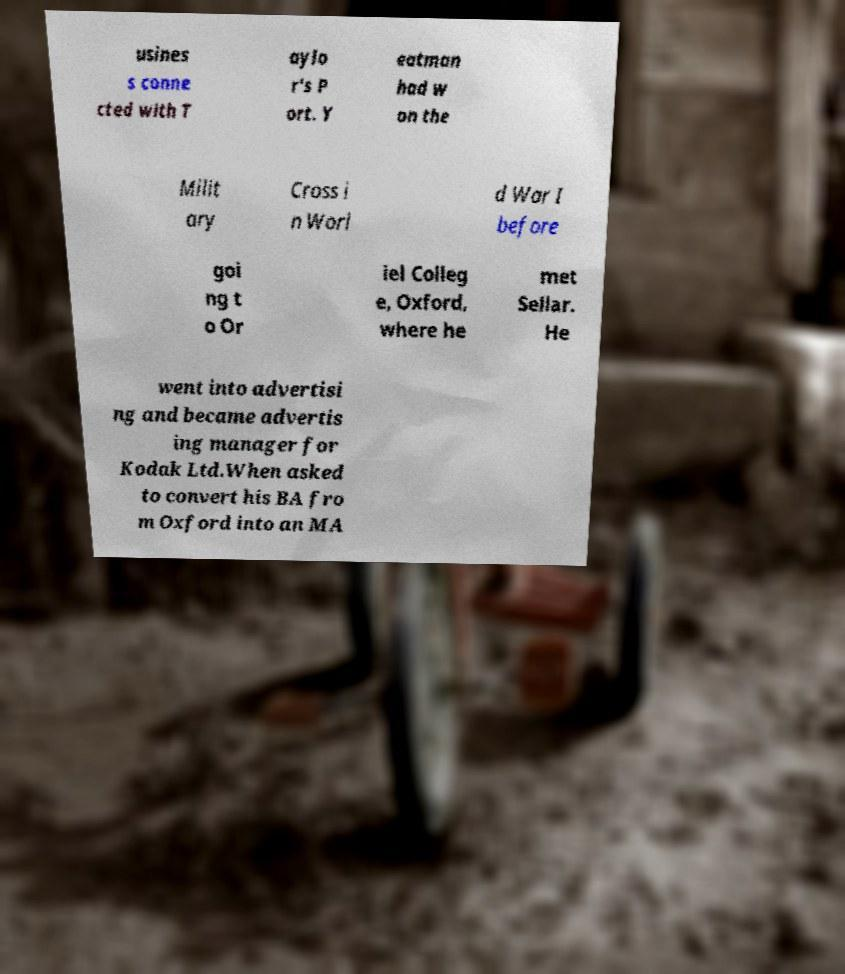Please read and relay the text visible in this image. What does it say? usines s conne cted with T aylo r's P ort. Y eatman had w on the Milit ary Cross i n Worl d War I before goi ng t o Or iel Colleg e, Oxford, where he met Sellar. He went into advertisi ng and became advertis ing manager for Kodak Ltd.When asked to convert his BA fro m Oxford into an MA 